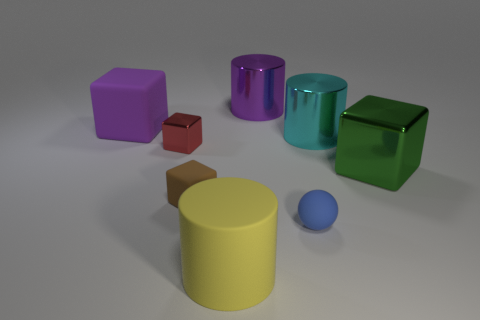If you were to arrange the objects by size, which one would come first and last? If ordered by size from smallest to largest, the tiny blue rubber ball would come first, due to its minuscule size relative to the other objects. The large yellow cylinder would come last, as it is the most substantial object in the scene in terms of both height and volume. 